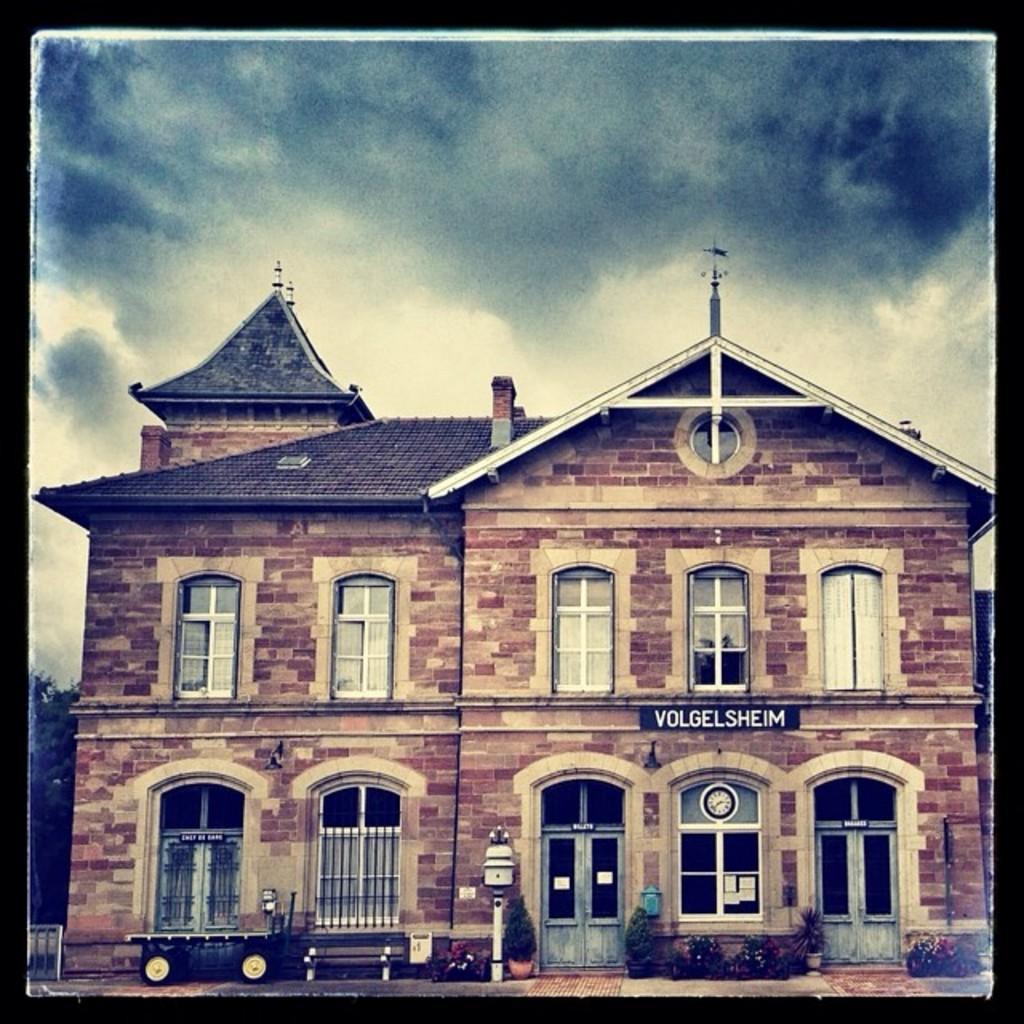Describe this image in one or two sentences. In this picture we can see a building, few plants, cart and clouds. 